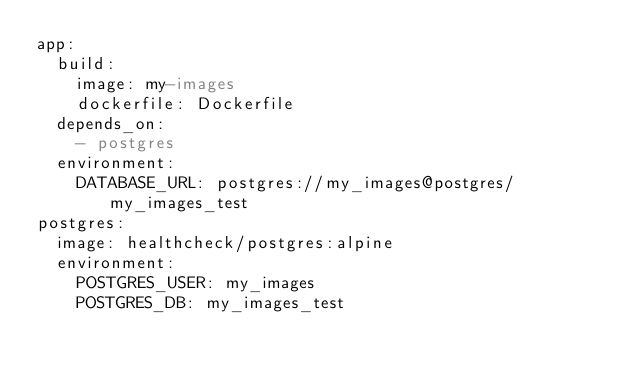<code> <loc_0><loc_0><loc_500><loc_500><_YAML_>app:
  build:
    image: my-images
    dockerfile: Dockerfile
  depends_on:
    - postgres
  environment:
    DATABASE_URL: postgres://my_images@postgres/my_images_test
postgres:
  image: healthcheck/postgres:alpine
  environment:
    POSTGRES_USER: my_images
    POSTGRES_DB: my_images_test
</code> 